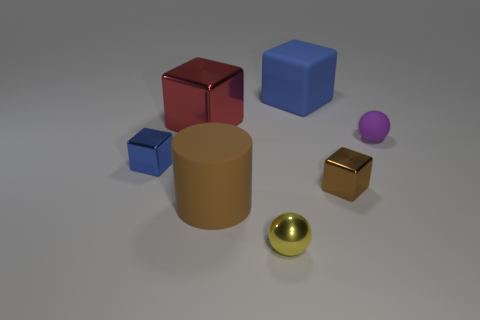What number of cubes have the same size as the yellow shiny ball?
Your answer should be compact. 2. There is a metallic object on the left side of the red metallic cube; is it the same size as the brown thing that is on the left side of the tiny brown metallic cube?
Offer a very short reply. No. What shape is the large matte thing that is in front of the large blue object?
Provide a short and direct response. Cylinder. What material is the small brown object right of the blue cube that is right of the large red cube?
Make the answer very short. Metal. Are there any blocks of the same color as the large rubber cylinder?
Provide a succinct answer. Yes. Is the size of the yellow object the same as the blue block that is in front of the big metallic cube?
Your response must be concise. Yes. There is a red object that is left of the blue cube that is behind the small blue cube; what number of yellow objects are behind it?
Offer a terse response. 0. How many balls are in front of the big cylinder?
Give a very brief answer. 1. What color is the tiny ball that is left of the matte thing behind the tiny rubber thing?
Offer a very short reply. Yellow. How many other objects are the same material as the small purple sphere?
Offer a terse response. 2. 